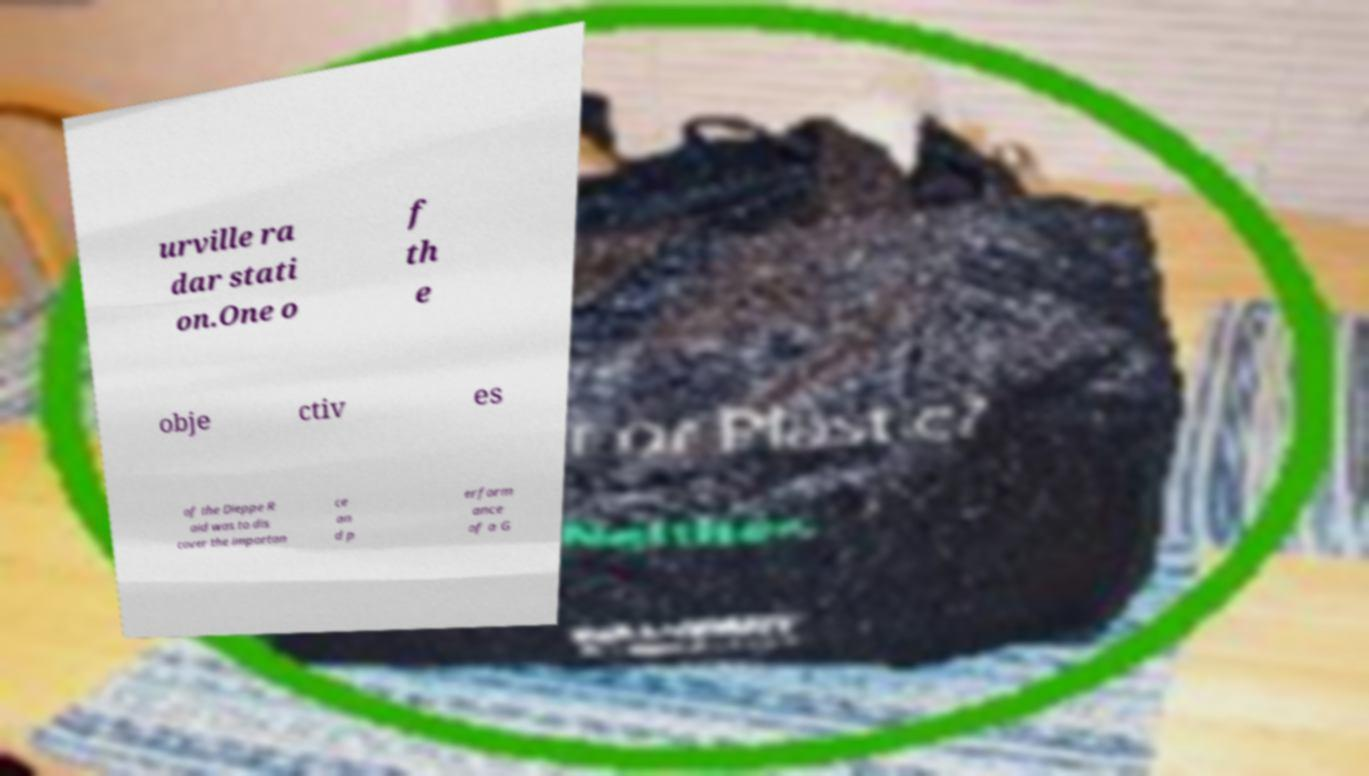Could you assist in decoding the text presented in this image and type it out clearly? urville ra dar stati on.One o f th e obje ctiv es of the Dieppe R aid was to dis cover the importan ce an d p erform ance of a G 